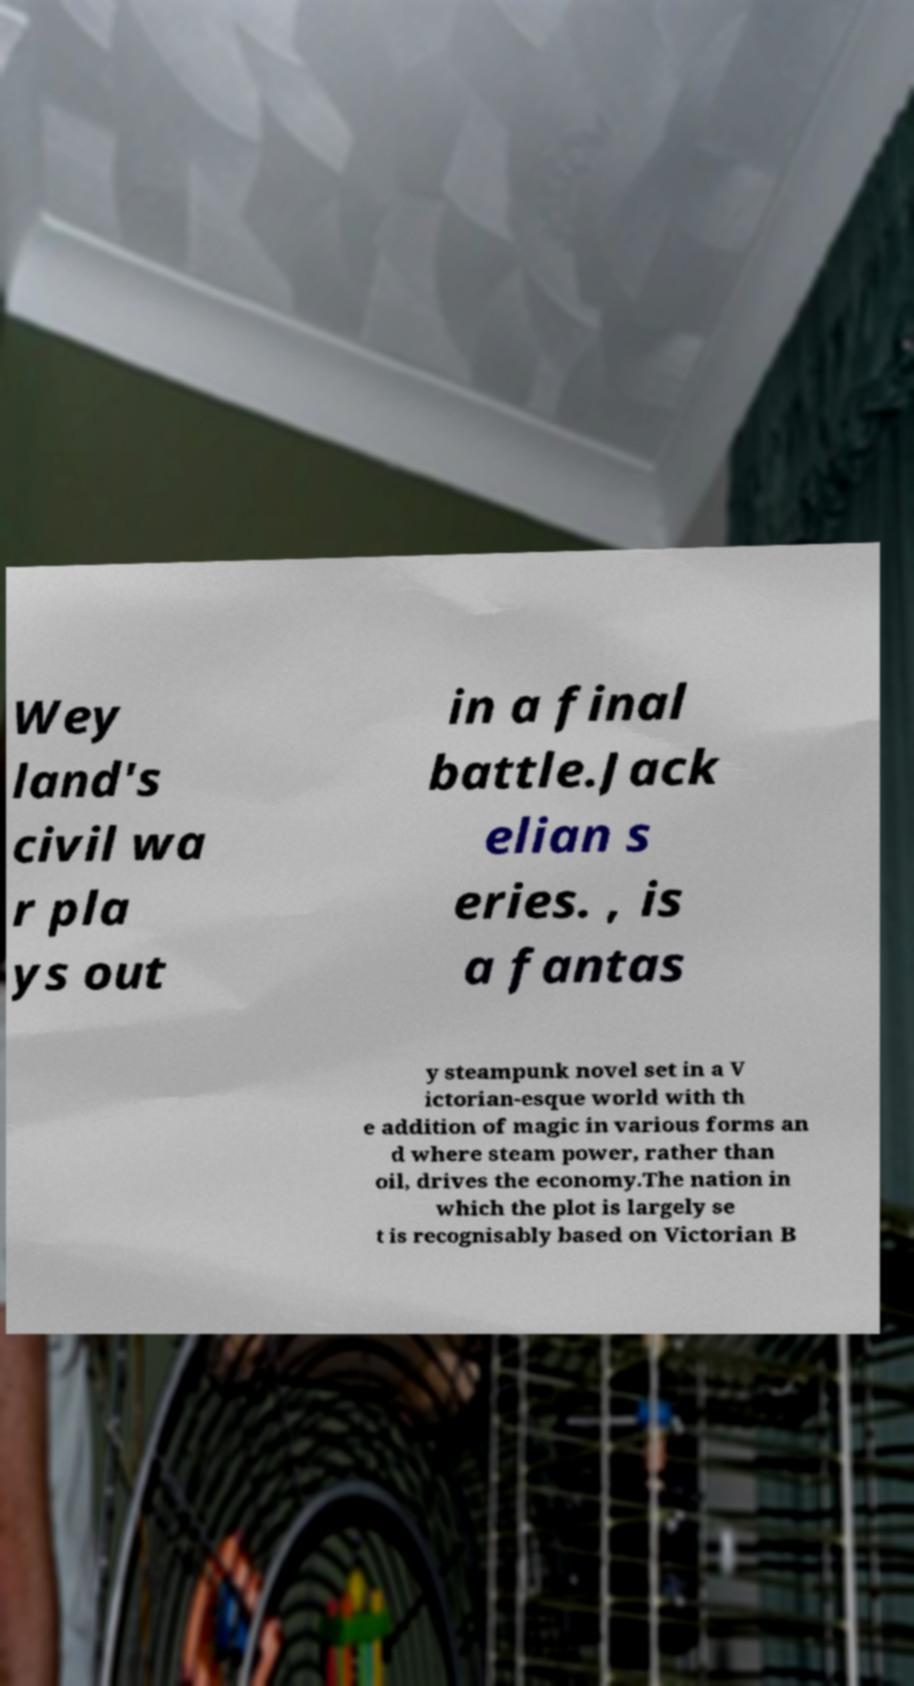Could you assist in decoding the text presented in this image and type it out clearly? Wey land's civil wa r pla ys out in a final battle.Jack elian s eries. , is a fantas y steampunk novel set in a V ictorian-esque world with th e addition of magic in various forms an d where steam power, rather than oil, drives the economy.The nation in which the plot is largely se t is recognisably based on Victorian B 